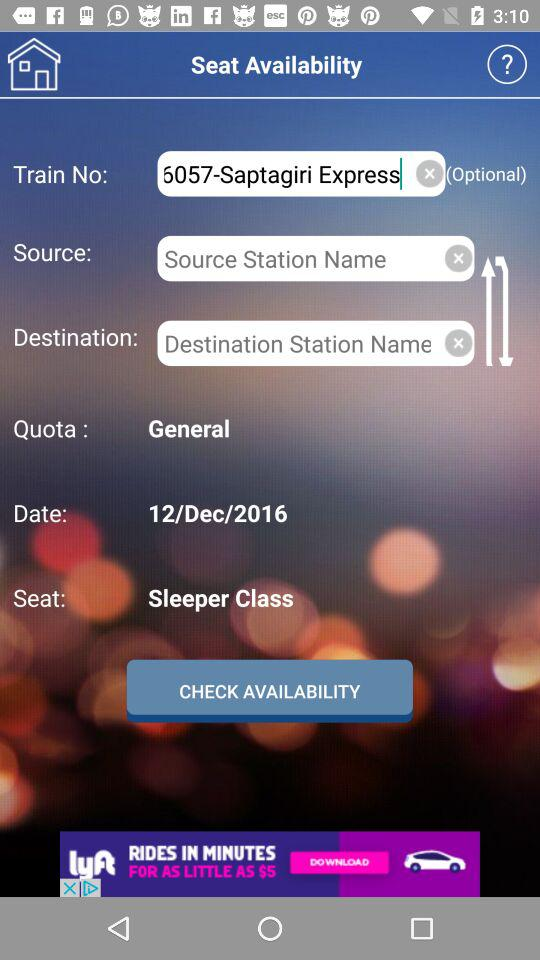What is the train number and train name? The train number is 6057 and the train name is Saptagiri Express. 